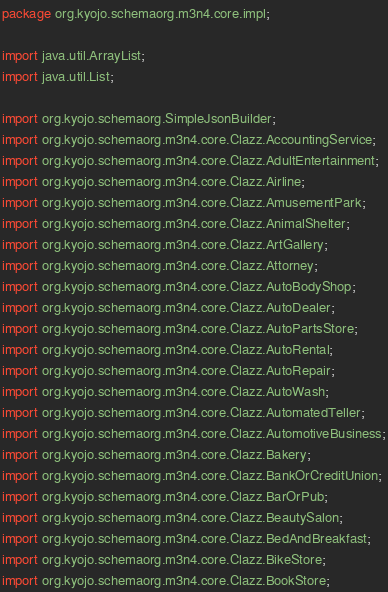<code> <loc_0><loc_0><loc_500><loc_500><_Java_>package org.kyojo.schemaorg.m3n4.core.impl;

import java.util.ArrayList;
import java.util.List;

import org.kyojo.schemaorg.SimpleJsonBuilder;
import org.kyojo.schemaorg.m3n4.core.Clazz.AccountingService;
import org.kyojo.schemaorg.m3n4.core.Clazz.AdultEntertainment;
import org.kyojo.schemaorg.m3n4.core.Clazz.Airline;
import org.kyojo.schemaorg.m3n4.core.Clazz.AmusementPark;
import org.kyojo.schemaorg.m3n4.core.Clazz.AnimalShelter;
import org.kyojo.schemaorg.m3n4.core.Clazz.ArtGallery;
import org.kyojo.schemaorg.m3n4.core.Clazz.Attorney;
import org.kyojo.schemaorg.m3n4.core.Clazz.AutoBodyShop;
import org.kyojo.schemaorg.m3n4.core.Clazz.AutoDealer;
import org.kyojo.schemaorg.m3n4.core.Clazz.AutoPartsStore;
import org.kyojo.schemaorg.m3n4.core.Clazz.AutoRental;
import org.kyojo.schemaorg.m3n4.core.Clazz.AutoRepair;
import org.kyojo.schemaorg.m3n4.core.Clazz.AutoWash;
import org.kyojo.schemaorg.m3n4.core.Clazz.AutomatedTeller;
import org.kyojo.schemaorg.m3n4.core.Clazz.AutomotiveBusiness;
import org.kyojo.schemaorg.m3n4.core.Clazz.Bakery;
import org.kyojo.schemaorg.m3n4.core.Clazz.BankOrCreditUnion;
import org.kyojo.schemaorg.m3n4.core.Clazz.BarOrPub;
import org.kyojo.schemaorg.m3n4.core.Clazz.BeautySalon;
import org.kyojo.schemaorg.m3n4.core.Clazz.BedAndBreakfast;
import org.kyojo.schemaorg.m3n4.core.Clazz.BikeStore;
import org.kyojo.schemaorg.m3n4.core.Clazz.BookStore;</code> 